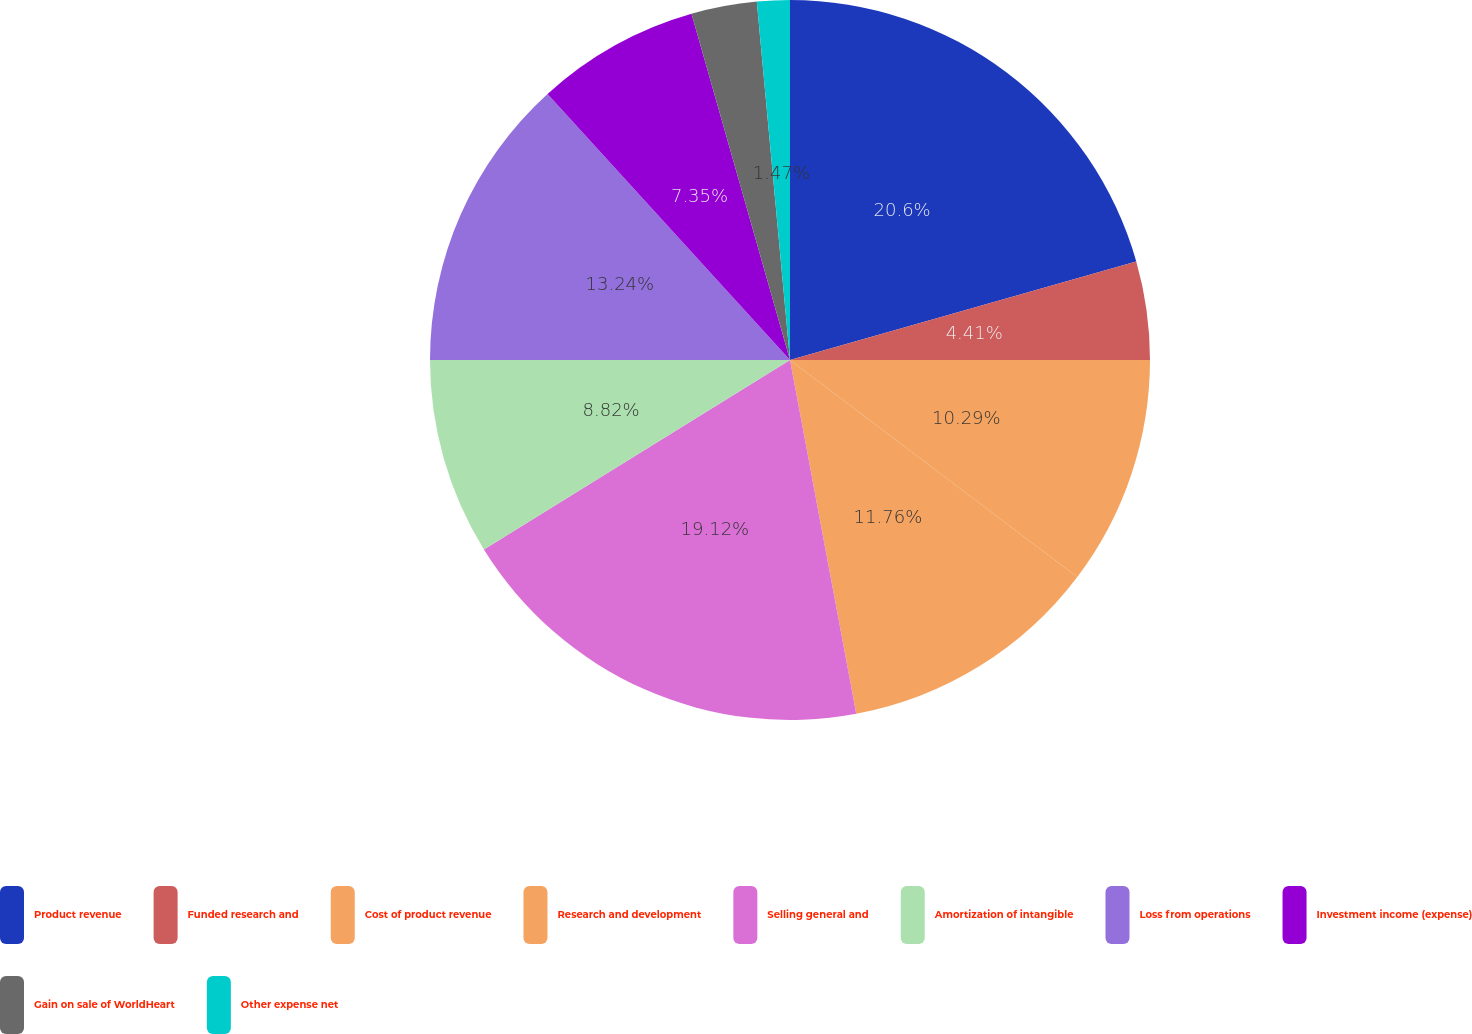Convert chart. <chart><loc_0><loc_0><loc_500><loc_500><pie_chart><fcel>Product revenue<fcel>Funded research and<fcel>Cost of product revenue<fcel>Research and development<fcel>Selling general and<fcel>Amortization of intangible<fcel>Loss from operations<fcel>Investment income (expense)<fcel>Gain on sale of WorldHeart<fcel>Other expense net<nl><fcel>20.59%<fcel>4.41%<fcel>10.29%<fcel>11.76%<fcel>19.12%<fcel>8.82%<fcel>13.24%<fcel>7.35%<fcel>2.94%<fcel>1.47%<nl></chart> 